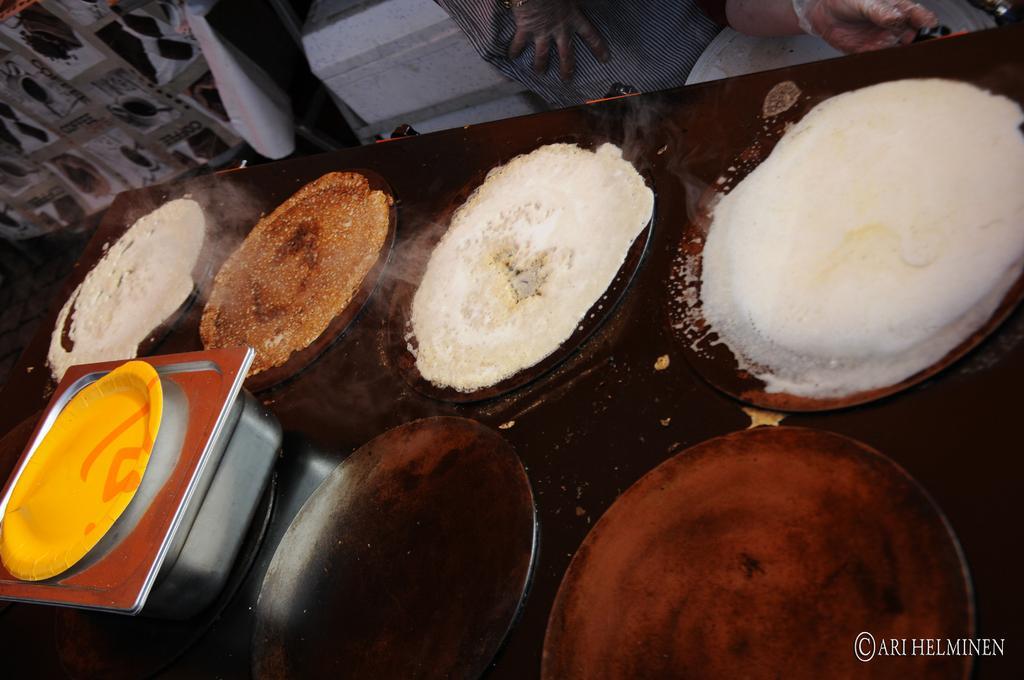Describe this image in one or two sentences. In this picture there is food on the pans. There are pans and there is a bowl on the table and there is a plate on the bowl. At the back there is a person standing behind the table and there is a bowl and there is an object and there it looks like a cover on the rod and there is a poster on the wall. At the bottom right there is text. 